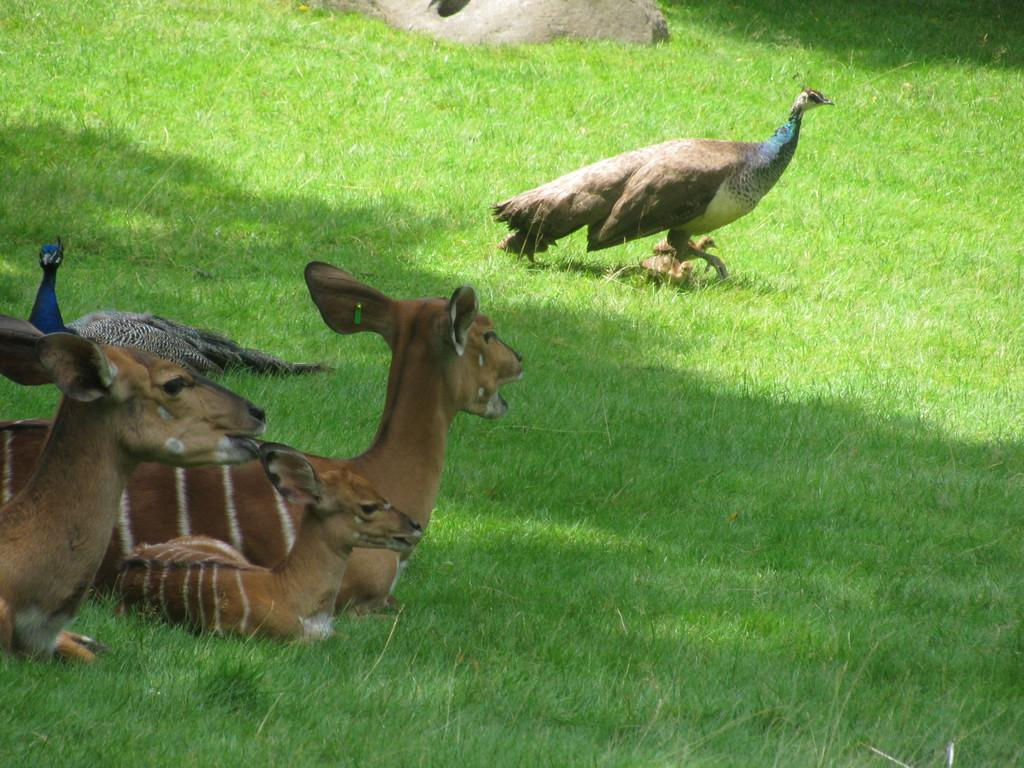What type of ground is visible in the image? There is grass ground in the image. What can be observed on the grass ground? There are shadows visible on the grass ground. How many deer are present in the image? There are three deer in the image. What other animals can be seen in the image besides deer? There is one peacock and one peahen in the image. How many birds are visible on the right side of the image? There are two birds on the right side of the image. What type of rings can be seen on the peacock's legs in the image? There are no rings visible on the peacock's legs in the image. How many screws are holding the peahen's feathers together in the image? There are no screws present in the image, as birds do not have screws holding their feathers together. 